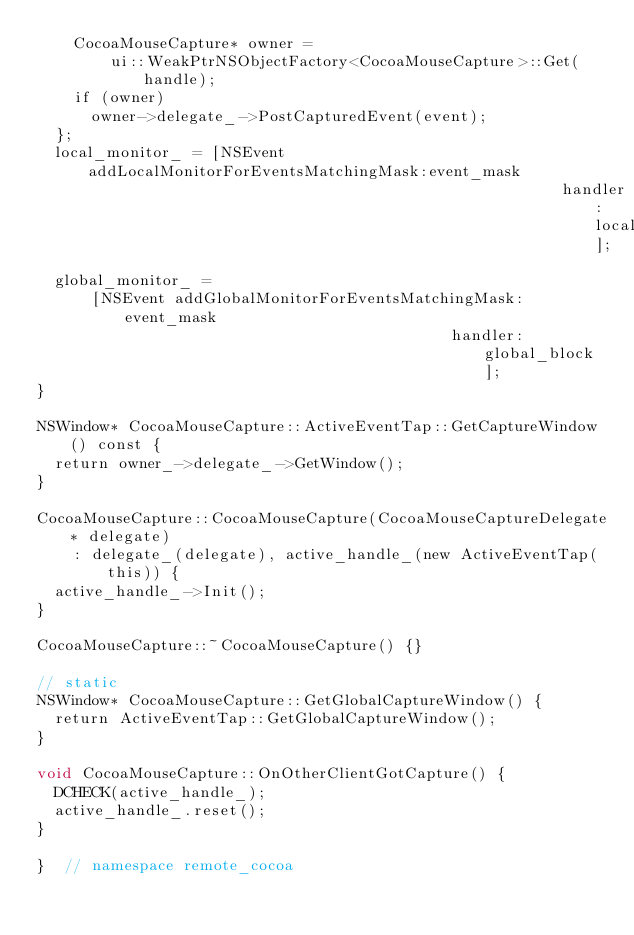<code> <loc_0><loc_0><loc_500><loc_500><_ObjectiveC_>    CocoaMouseCapture* owner =
        ui::WeakPtrNSObjectFactory<CocoaMouseCapture>::Get(handle);
    if (owner)
      owner->delegate_->PostCapturedEvent(event);
  };
  local_monitor_ = [NSEvent addLocalMonitorForEventsMatchingMask:event_mask
                                                         handler:local_block];
  global_monitor_ =
      [NSEvent addGlobalMonitorForEventsMatchingMask:event_mask
                                             handler:global_block];
}

NSWindow* CocoaMouseCapture::ActiveEventTap::GetCaptureWindow() const {
  return owner_->delegate_->GetWindow();
}

CocoaMouseCapture::CocoaMouseCapture(CocoaMouseCaptureDelegate* delegate)
    : delegate_(delegate), active_handle_(new ActiveEventTap(this)) {
  active_handle_->Init();
}

CocoaMouseCapture::~CocoaMouseCapture() {}

// static
NSWindow* CocoaMouseCapture::GetGlobalCaptureWindow() {
  return ActiveEventTap::GetGlobalCaptureWindow();
}

void CocoaMouseCapture::OnOtherClientGotCapture() {
  DCHECK(active_handle_);
  active_handle_.reset();
}

}  // namespace remote_cocoa
</code> 